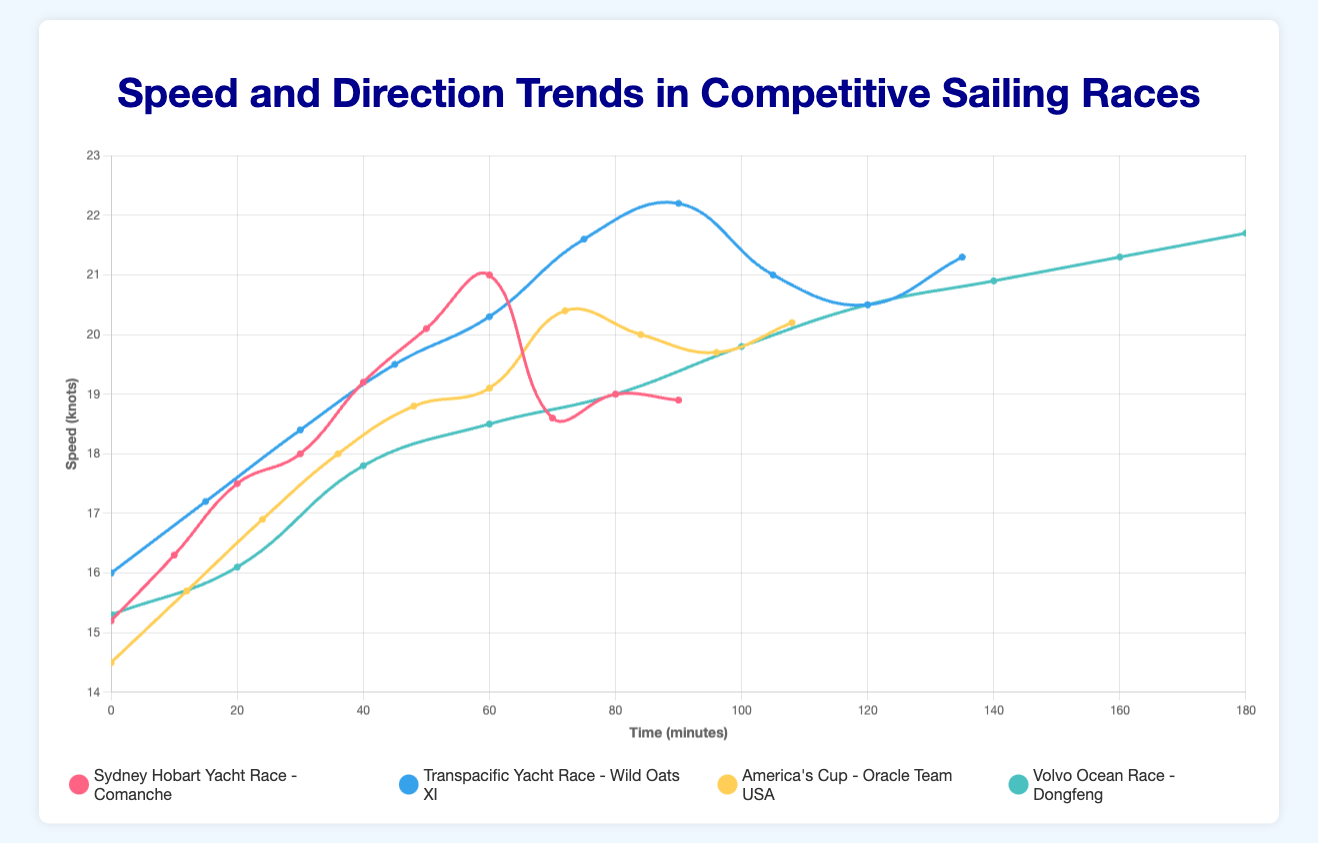Which race had the highest maximum speed? The highest maximum speed can be found by looking at the peak values across all four races. By examining the speed curves, we see that "Wild Oats XI" in the Transpacific Yacht Race reaches the highest speed of 22.2 knots.
Answer: Transpacific Yacht Race What is the overall speed trend for Comanche in the Sydney Hobart Yacht Race? Observing the speed curve for Comanche, we see it starts at 15.2 knots, increases steadily to a peak of 21.0 knots around 60 minutes, then drops somewhat, and settles around 18.9 knots. The trend shows an initial increase, a peak, followed by a slight decrease.
Answer: Increase then slight decrease Which boat maintained a more consistent speed, Dongfeng in the Volvo Ocean Race or Oracle Team USA in America's Cup? Consistency in speed can be observed by looking at the fluctuation of the speed lines. Dongfeng's speed steadily increases with smaller variations compared to Oracle Team USA, which has more fluctuations around its trend line.
Answer: Dongfeng At what time did Wild Oats XI in the Transpacific Yacht Race achieve its highest speed? Based on the speed curve for Wild Oats XI, the highest speed of 22.2 knots occurs at 90 minutes.
Answer: 90 minutes Compare the direction changes of Comanche and Dongfeng over their respective races. Which boat had a wider range of direction adjustments? Comparing the direction curves, Comanche's direction ranges from 135° to 162° (27° range), while Dongfeng's direction ranges from 123° to 150° (27° range). Both have the same range of direction adjustments.
Answer: Both have the same range For Oracle Team USA in America's Cup, what is the relationship between their speed and direction after 60 minutes? After 60 minutes, Oracle Team USA's speed shows a fluctuating pattern (around 20 knots), and their direction steadily increases from 135° to 155°.
Answer: Speed fluctuates as direction increases What is the average speed of Dongfeng in the Volvo Ocean Race? Average speed can be calculated by summing all speed values for Dongfeng and dividing by the number of data points: (15.3 + 16.1 + 17.8 + 18.5 + 19.0 + 19.8 + 20.5 + 20.9 + 21.3 + 21.7) / 10 = 191.9 / 10 = 19.19 knots.
Answer: 19.19 knots During which time interval did Comanche experience the steepest increase in speed? The steepest increase is observed by the steepest slope in the speed line. For Comanche, between 50 to 60 minutes, speed increases from 20.1 to 21.0 knots, the rate is 0.9 knots in 10 minutes, the steepest among the intervals.
Answer: 50 to 60 minutes Which boat changed its direction the most frequently within a short time frame? Analyzing the direction curves, Oracle Team USA shows more frequent and consistent direction changes (every 12 minutes) compared to others.
Answer: Oracle Team USA 